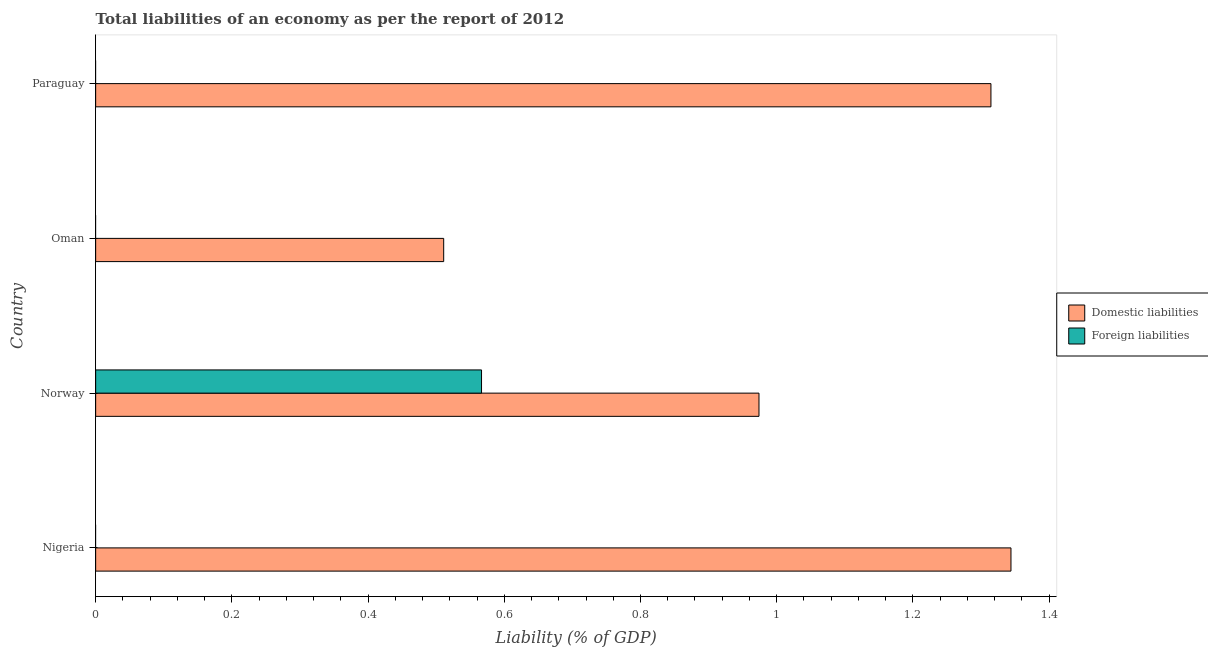How many different coloured bars are there?
Offer a very short reply. 2. How many bars are there on the 3rd tick from the bottom?
Give a very brief answer. 1. In how many cases, is the number of bars for a given country not equal to the number of legend labels?
Provide a succinct answer. 3. What is the incurrence of domestic liabilities in Norway?
Provide a short and direct response. 0.97. Across all countries, what is the maximum incurrence of foreign liabilities?
Offer a very short reply. 0.57. Across all countries, what is the minimum incurrence of domestic liabilities?
Your answer should be very brief. 0.51. In which country was the incurrence of foreign liabilities maximum?
Offer a terse response. Norway. What is the total incurrence of foreign liabilities in the graph?
Your response must be concise. 0.57. What is the difference between the incurrence of domestic liabilities in Oman and that in Paraguay?
Offer a very short reply. -0.8. What is the difference between the incurrence of foreign liabilities in Nigeria and the incurrence of domestic liabilities in Paraguay?
Make the answer very short. -1.31. What is the average incurrence of foreign liabilities per country?
Ensure brevity in your answer.  0.14. What is the difference between the incurrence of foreign liabilities and incurrence of domestic liabilities in Norway?
Your response must be concise. -0.41. What is the ratio of the incurrence of domestic liabilities in Oman to that in Paraguay?
Keep it short and to the point. 0.39. Is the incurrence of domestic liabilities in Oman less than that in Paraguay?
Offer a terse response. Yes. What is the difference between the highest and the second highest incurrence of domestic liabilities?
Offer a very short reply. 0.03. What is the difference between the highest and the lowest incurrence of domestic liabilities?
Keep it short and to the point. 0.83. In how many countries, is the incurrence of domestic liabilities greater than the average incurrence of domestic liabilities taken over all countries?
Offer a terse response. 2. Is the sum of the incurrence of domestic liabilities in Nigeria and Paraguay greater than the maximum incurrence of foreign liabilities across all countries?
Provide a short and direct response. Yes. Are all the bars in the graph horizontal?
Give a very brief answer. Yes. How many countries are there in the graph?
Offer a terse response. 4. What is the difference between two consecutive major ticks on the X-axis?
Provide a succinct answer. 0.2. Are the values on the major ticks of X-axis written in scientific E-notation?
Keep it short and to the point. No. Does the graph contain grids?
Give a very brief answer. No. Where does the legend appear in the graph?
Make the answer very short. Center right. How are the legend labels stacked?
Your answer should be compact. Vertical. What is the title of the graph?
Your answer should be compact. Total liabilities of an economy as per the report of 2012. What is the label or title of the X-axis?
Make the answer very short. Liability (% of GDP). What is the Liability (% of GDP) in Domestic liabilities in Nigeria?
Give a very brief answer. 1.34. What is the Liability (% of GDP) in Domestic liabilities in Norway?
Your answer should be compact. 0.97. What is the Liability (% of GDP) of Foreign liabilities in Norway?
Keep it short and to the point. 0.57. What is the Liability (% of GDP) of Domestic liabilities in Oman?
Offer a terse response. 0.51. What is the Liability (% of GDP) of Domestic liabilities in Paraguay?
Your answer should be very brief. 1.31. What is the Liability (% of GDP) in Foreign liabilities in Paraguay?
Your response must be concise. 0. Across all countries, what is the maximum Liability (% of GDP) of Domestic liabilities?
Keep it short and to the point. 1.34. Across all countries, what is the maximum Liability (% of GDP) in Foreign liabilities?
Offer a terse response. 0.57. Across all countries, what is the minimum Liability (% of GDP) in Domestic liabilities?
Provide a succinct answer. 0.51. Across all countries, what is the minimum Liability (% of GDP) of Foreign liabilities?
Ensure brevity in your answer.  0. What is the total Liability (% of GDP) in Domestic liabilities in the graph?
Offer a terse response. 4.14. What is the total Liability (% of GDP) in Foreign liabilities in the graph?
Ensure brevity in your answer.  0.57. What is the difference between the Liability (% of GDP) in Domestic liabilities in Nigeria and that in Norway?
Provide a succinct answer. 0.37. What is the difference between the Liability (% of GDP) of Domestic liabilities in Nigeria and that in Oman?
Your answer should be very brief. 0.83. What is the difference between the Liability (% of GDP) in Domestic liabilities in Nigeria and that in Paraguay?
Offer a very short reply. 0.03. What is the difference between the Liability (% of GDP) in Domestic liabilities in Norway and that in Oman?
Your response must be concise. 0.46. What is the difference between the Liability (% of GDP) of Domestic liabilities in Norway and that in Paraguay?
Your response must be concise. -0.34. What is the difference between the Liability (% of GDP) in Domestic liabilities in Oman and that in Paraguay?
Give a very brief answer. -0.8. What is the difference between the Liability (% of GDP) in Domestic liabilities in Nigeria and the Liability (% of GDP) in Foreign liabilities in Norway?
Ensure brevity in your answer.  0.78. What is the average Liability (% of GDP) of Domestic liabilities per country?
Your answer should be compact. 1.04. What is the average Liability (% of GDP) of Foreign liabilities per country?
Keep it short and to the point. 0.14. What is the difference between the Liability (% of GDP) in Domestic liabilities and Liability (% of GDP) in Foreign liabilities in Norway?
Your answer should be compact. 0.41. What is the ratio of the Liability (% of GDP) of Domestic liabilities in Nigeria to that in Norway?
Ensure brevity in your answer.  1.38. What is the ratio of the Liability (% of GDP) of Domestic liabilities in Nigeria to that in Oman?
Provide a short and direct response. 2.63. What is the ratio of the Liability (% of GDP) in Domestic liabilities in Nigeria to that in Paraguay?
Provide a succinct answer. 1.02. What is the ratio of the Liability (% of GDP) in Domestic liabilities in Norway to that in Oman?
Provide a short and direct response. 1.91. What is the ratio of the Liability (% of GDP) of Domestic liabilities in Norway to that in Paraguay?
Provide a short and direct response. 0.74. What is the ratio of the Liability (% of GDP) of Domestic liabilities in Oman to that in Paraguay?
Your answer should be very brief. 0.39. What is the difference between the highest and the second highest Liability (% of GDP) in Domestic liabilities?
Provide a short and direct response. 0.03. What is the difference between the highest and the lowest Liability (% of GDP) of Domestic liabilities?
Offer a terse response. 0.83. What is the difference between the highest and the lowest Liability (% of GDP) in Foreign liabilities?
Keep it short and to the point. 0.57. 